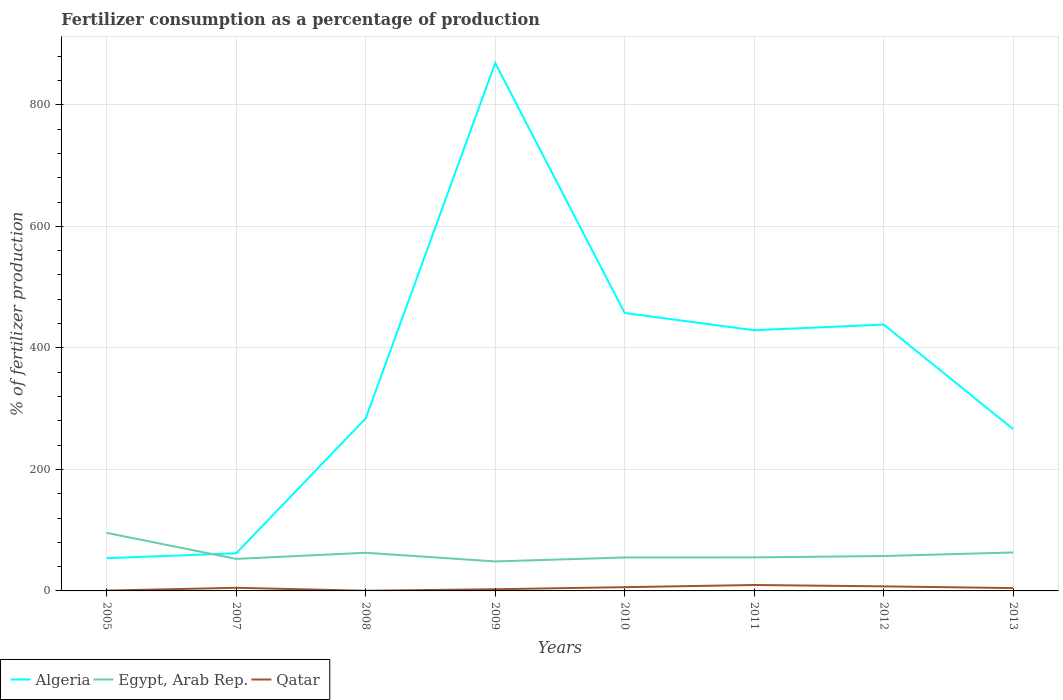Does the line corresponding to Algeria intersect with the line corresponding to Qatar?
Ensure brevity in your answer.  No. Across all years, what is the maximum percentage of fertilizers consumed in Qatar?
Your answer should be very brief. 0.26. In which year was the percentage of fertilizers consumed in Egypt, Arab Rep. maximum?
Your answer should be compact. 2009. What is the total percentage of fertilizers consumed in Algeria in the graph?
Offer a very short reply. 172.19. What is the difference between the highest and the second highest percentage of fertilizers consumed in Algeria?
Provide a succinct answer. 815.1. Is the percentage of fertilizers consumed in Qatar strictly greater than the percentage of fertilizers consumed in Algeria over the years?
Give a very brief answer. Yes. How many lines are there?
Keep it short and to the point. 3. Where does the legend appear in the graph?
Your answer should be very brief. Bottom left. What is the title of the graph?
Keep it short and to the point. Fertilizer consumption as a percentage of production. What is the label or title of the X-axis?
Provide a short and direct response. Years. What is the label or title of the Y-axis?
Offer a very short reply. % of fertilizer production. What is the % of fertilizer production in Algeria in 2005?
Your answer should be very brief. 53.9. What is the % of fertilizer production of Egypt, Arab Rep. in 2005?
Your answer should be compact. 95.53. What is the % of fertilizer production of Qatar in 2005?
Your answer should be compact. 0.54. What is the % of fertilizer production of Algeria in 2007?
Ensure brevity in your answer.  61.95. What is the % of fertilizer production in Egypt, Arab Rep. in 2007?
Provide a succinct answer. 52.73. What is the % of fertilizer production of Qatar in 2007?
Offer a very short reply. 5.16. What is the % of fertilizer production of Algeria in 2008?
Make the answer very short. 283.96. What is the % of fertilizer production of Egypt, Arab Rep. in 2008?
Your answer should be very brief. 62.8. What is the % of fertilizer production of Qatar in 2008?
Give a very brief answer. 0.26. What is the % of fertilizer production of Algeria in 2009?
Provide a succinct answer. 869. What is the % of fertilizer production of Egypt, Arab Rep. in 2009?
Ensure brevity in your answer.  48.52. What is the % of fertilizer production of Qatar in 2009?
Your response must be concise. 2.78. What is the % of fertilizer production in Algeria in 2010?
Make the answer very short. 457.43. What is the % of fertilizer production of Egypt, Arab Rep. in 2010?
Ensure brevity in your answer.  55.04. What is the % of fertilizer production of Qatar in 2010?
Your response must be concise. 6.17. What is the % of fertilizer production in Algeria in 2011?
Make the answer very short. 429.09. What is the % of fertilizer production in Egypt, Arab Rep. in 2011?
Provide a short and direct response. 55.18. What is the % of fertilizer production in Qatar in 2011?
Make the answer very short. 9.75. What is the % of fertilizer production in Algeria in 2012?
Offer a terse response. 438.44. What is the % of fertilizer production in Egypt, Arab Rep. in 2012?
Offer a terse response. 57.44. What is the % of fertilizer production in Qatar in 2012?
Your response must be concise. 7.5. What is the % of fertilizer production in Algeria in 2013?
Your answer should be very brief. 266.25. What is the % of fertilizer production of Egypt, Arab Rep. in 2013?
Offer a terse response. 63.31. What is the % of fertilizer production of Qatar in 2013?
Provide a short and direct response. 4.65. Across all years, what is the maximum % of fertilizer production in Algeria?
Give a very brief answer. 869. Across all years, what is the maximum % of fertilizer production of Egypt, Arab Rep.?
Make the answer very short. 95.53. Across all years, what is the maximum % of fertilizer production in Qatar?
Your response must be concise. 9.75. Across all years, what is the minimum % of fertilizer production in Algeria?
Make the answer very short. 53.9. Across all years, what is the minimum % of fertilizer production of Egypt, Arab Rep.?
Your answer should be compact. 48.52. Across all years, what is the minimum % of fertilizer production in Qatar?
Your response must be concise. 0.26. What is the total % of fertilizer production of Algeria in the graph?
Your answer should be very brief. 2860.02. What is the total % of fertilizer production in Egypt, Arab Rep. in the graph?
Make the answer very short. 490.56. What is the total % of fertilizer production in Qatar in the graph?
Give a very brief answer. 36.81. What is the difference between the % of fertilizer production in Algeria in 2005 and that in 2007?
Give a very brief answer. -8.04. What is the difference between the % of fertilizer production in Egypt, Arab Rep. in 2005 and that in 2007?
Offer a very short reply. 42.8. What is the difference between the % of fertilizer production of Qatar in 2005 and that in 2007?
Provide a succinct answer. -4.63. What is the difference between the % of fertilizer production in Algeria in 2005 and that in 2008?
Offer a terse response. -230.05. What is the difference between the % of fertilizer production of Egypt, Arab Rep. in 2005 and that in 2008?
Keep it short and to the point. 32.74. What is the difference between the % of fertilizer production of Qatar in 2005 and that in 2008?
Your answer should be very brief. 0.28. What is the difference between the % of fertilizer production in Algeria in 2005 and that in 2009?
Your response must be concise. -815.1. What is the difference between the % of fertilizer production in Egypt, Arab Rep. in 2005 and that in 2009?
Make the answer very short. 47.01. What is the difference between the % of fertilizer production of Qatar in 2005 and that in 2009?
Provide a short and direct response. -2.24. What is the difference between the % of fertilizer production in Algeria in 2005 and that in 2010?
Give a very brief answer. -403.53. What is the difference between the % of fertilizer production of Egypt, Arab Rep. in 2005 and that in 2010?
Offer a very short reply. 40.49. What is the difference between the % of fertilizer production of Qatar in 2005 and that in 2010?
Provide a short and direct response. -5.64. What is the difference between the % of fertilizer production of Algeria in 2005 and that in 2011?
Make the answer very short. -375.19. What is the difference between the % of fertilizer production in Egypt, Arab Rep. in 2005 and that in 2011?
Your answer should be very brief. 40.36. What is the difference between the % of fertilizer production in Qatar in 2005 and that in 2011?
Ensure brevity in your answer.  -9.21. What is the difference between the % of fertilizer production of Algeria in 2005 and that in 2012?
Make the answer very short. -384.54. What is the difference between the % of fertilizer production in Egypt, Arab Rep. in 2005 and that in 2012?
Offer a terse response. 38.09. What is the difference between the % of fertilizer production in Qatar in 2005 and that in 2012?
Ensure brevity in your answer.  -6.96. What is the difference between the % of fertilizer production in Algeria in 2005 and that in 2013?
Give a very brief answer. -212.35. What is the difference between the % of fertilizer production of Egypt, Arab Rep. in 2005 and that in 2013?
Give a very brief answer. 32.23. What is the difference between the % of fertilizer production in Qatar in 2005 and that in 2013?
Provide a succinct answer. -4.11. What is the difference between the % of fertilizer production in Algeria in 2007 and that in 2008?
Ensure brevity in your answer.  -222.01. What is the difference between the % of fertilizer production of Egypt, Arab Rep. in 2007 and that in 2008?
Offer a very short reply. -10.07. What is the difference between the % of fertilizer production in Qatar in 2007 and that in 2008?
Your answer should be compact. 4.9. What is the difference between the % of fertilizer production of Algeria in 2007 and that in 2009?
Provide a succinct answer. -807.06. What is the difference between the % of fertilizer production of Egypt, Arab Rep. in 2007 and that in 2009?
Provide a short and direct response. 4.21. What is the difference between the % of fertilizer production in Qatar in 2007 and that in 2009?
Ensure brevity in your answer.  2.38. What is the difference between the % of fertilizer production in Algeria in 2007 and that in 2010?
Your answer should be very brief. -395.49. What is the difference between the % of fertilizer production in Egypt, Arab Rep. in 2007 and that in 2010?
Provide a succinct answer. -2.31. What is the difference between the % of fertilizer production in Qatar in 2007 and that in 2010?
Offer a very short reply. -1.01. What is the difference between the % of fertilizer production in Algeria in 2007 and that in 2011?
Keep it short and to the point. -367.14. What is the difference between the % of fertilizer production in Egypt, Arab Rep. in 2007 and that in 2011?
Your answer should be very brief. -2.45. What is the difference between the % of fertilizer production of Qatar in 2007 and that in 2011?
Keep it short and to the point. -4.59. What is the difference between the % of fertilizer production in Algeria in 2007 and that in 2012?
Provide a short and direct response. -376.49. What is the difference between the % of fertilizer production in Egypt, Arab Rep. in 2007 and that in 2012?
Offer a terse response. -4.71. What is the difference between the % of fertilizer production of Qatar in 2007 and that in 2012?
Provide a short and direct response. -2.34. What is the difference between the % of fertilizer production of Algeria in 2007 and that in 2013?
Provide a succinct answer. -204.3. What is the difference between the % of fertilizer production of Egypt, Arab Rep. in 2007 and that in 2013?
Your answer should be very brief. -10.58. What is the difference between the % of fertilizer production of Qatar in 2007 and that in 2013?
Provide a succinct answer. 0.51. What is the difference between the % of fertilizer production in Algeria in 2008 and that in 2009?
Give a very brief answer. -585.05. What is the difference between the % of fertilizer production of Egypt, Arab Rep. in 2008 and that in 2009?
Provide a succinct answer. 14.28. What is the difference between the % of fertilizer production in Qatar in 2008 and that in 2009?
Make the answer very short. -2.52. What is the difference between the % of fertilizer production in Algeria in 2008 and that in 2010?
Make the answer very short. -173.48. What is the difference between the % of fertilizer production in Egypt, Arab Rep. in 2008 and that in 2010?
Your response must be concise. 7.76. What is the difference between the % of fertilizer production of Qatar in 2008 and that in 2010?
Give a very brief answer. -5.91. What is the difference between the % of fertilizer production of Algeria in 2008 and that in 2011?
Keep it short and to the point. -145.13. What is the difference between the % of fertilizer production of Egypt, Arab Rep. in 2008 and that in 2011?
Provide a short and direct response. 7.62. What is the difference between the % of fertilizer production in Qatar in 2008 and that in 2011?
Provide a short and direct response. -9.49. What is the difference between the % of fertilizer production in Algeria in 2008 and that in 2012?
Provide a succinct answer. -154.48. What is the difference between the % of fertilizer production in Egypt, Arab Rep. in 2008 and that in 2012?
Your response must be concise. 5.36. What is the difference between the % of fertilizer production in Qatar in 2008 and that in 2012?
Your answer should be compact. -7.24. What is the difference between the % of fertilizer production in Algeria in 2008 and that in 2013?
Ensure brevity in your answer.  17.71. What is the difference between the % of fertilizer production of Egypt, Arab Rep. in 2008 and that in 2013?
Give a very brief answer. -0.51. What is the difference between the % of fertilizer production in Qatar in 2008 and that in 2013?
Offer a terse response. -4.39. What is the difference between the % of fertilizer production of Algeria in 2009 and that in 2010?
Your response must be concise. 411.57. What is the difference between the % of fertilizer production in Egypt, Arab Rep. in 2009 and that in 2010?
Offer a terse response. -6.52. What is the difference between the % of fertilizer production in Qatar in 2009 and that in 2010?
Keep it short and to the point. -3.4. What is the difference between the % of fertilizer production of Algeria in 2009 and that in 2011?
Provide a succinct answer. 439.91. What is the difference between the % of fertilizer production in Egypt, Arab Rep. in 2009 and that in 2011?
Your answer should be very brief. -6.66. What is the difference between the % of fertilizer production in Qatar in 2009 and that in 2011?
Give a very brief answer. -6.97. What is the difference between the % of fertilizer production in Algeria in 2009 and that in 2012?
Provide a succinct answer. 430.57. What is the difference between the % of fertilizer production of Egypt, Arab Rep. in 2009 and that in 2012?
Your response must be concise. -8.92. What is the difference between the % of fertilizer production of Qatar in 2009 and that in 2012?
Offer a terse response. -4.72. What is the difference between the % of fertilizer production of Algeria in 2009 and that in 2013?
Your response must be concise. 602.76. What is the difference between the % of fertilizer production of Egypt, Arab Rep. in 2009 and that in 2013?
Your response must be concise. -14.79. What is the difference between the % of fertilizer production in Qatar in 2009 and that in 2013?
Keep it short and to the point. -1.87. What is the difference between the % of fertilizer production of Algeria in 2010 and that in 2011?
Keep it short and to the point. 28.34. What is the difference between the % of fertilizer production in Egypt, Arab Rep. in 2010 and that in 2011?
Ensure brevity in your answer.  -0.14. What is the difference between the % of fertilizer production of Qatar in 2010 and that in 2011?
Your response must be concise. -3.57. What is the difference between the % of fertilizer production in Algeria in 2010 and that in 2012?
Make the answer very short. 18.99. What is the difference between the % of fertilizer production of Egypt, Arab Rep. in 2010 and that in 2012?
Offer a terse response. -2.4. What is the difference between the % of fertilizer production in Qatar in 2010 and that in 2012?
Offer a very short reply. -1.33. What is the difference between the % of fertilizer production in Algeria in 2010 and that in 2013?
Provide a succinct answer. 191.18. What is the difference between the % of fertilizer production in Egypt, Arab Rep. in 2010 and that in 2013?
Your answer should be very brief. -8.27. What is the difference between the % of fertilizer production in Qatar in 2010 and that in 2013?
Provide a short and direct response. 1.52. What is the difference between the % of fertilizer production in Algeria in 2011 and that in 2012?
Offer a very short reply. -9.35. What is the difference between the % of fertilizer production of Egypt, Arab Rep. in 2011 and that in 2012?
Your answer should be compact. -2.26. What is the difference between the % of fertilizer production of Qatar in 2011 and that in 2012?
Keep it short and to the point. 2.25. What is the difference between the % of fertilizer production in Algeria in 2011 and that in 2013?
Your answer should be very brief. 162.84. What is the difference between the % of fertilizer production of Egypt, Arab Rep. in 2011 and that in 2013?
Keep it short and to the point. -8.13. What is the difference between the % of fertilizer production of Qatar in 2011 and that in 2013?
Make the answer very short. 5.1. What is the difference between the % of fertilizer production in Algeria in 2012 and that in 2013?
Keep it short and to the point. 172.19. What is the difference between the % of fertilizer production in Egypt, Arab Rep. in 2012 and that in 2013?
Your response must be concise. -5.87. What is the difference between the % of fertilizer production of Qatar in 2012 and that in 2013?
Keep it short and to the point. 2.85. What is the difference between the % of fertilizer production in Algeria in 2005 and the % of fertilizer production in Egypt, Arab Rep. in 2007?
Your answer should be very brief. 1.17. What is the difference between the % of fertilizer production in Algeria in 2005 and the % of fertilizer production in Qatar in 2007?
Offer a terse response. 48.74. What is the difference between the % of fertilizer production in Egypt, Arab Rep. in 2005 and the % of fertilizer production in Qatar in 2007?
Your answer should be compact. 90.37. What is the difference between the % of fertilizer production of Algeria in 2005 and the % of fertilizer production of Egypt, Arab Rep. in 2008?
Provide a succinct answer. -8.9. What is the difference between the % of fertilizer production in Algeria in 2005 and the % of fertilizer production in Qatar in 2008?
Your answer should be very brief. 53.64. What is the difference between the % of fertilizer production in Egypt, Arab Rep. in 2005 and the % of fertilizer production in Qatar in 2008?
Provide a short and direct response. 95.27. What is the difference between the % of fertilizer production of Algeria in 2005 and the % of fertilizer production of Egypt, Arab Rep. in 2009?
Ensure brevity in your answer.  5.38. What is the difference between the % of fertilizer production of Algeria in 2005 and the % of fertilizer production of Qatar in 2009?
Your response must be concise. 51.13. What is the difference between the % of fertilizer production in Egypt, Arab Rep. in 2005 and the % of fertilizer production in Qatar in 2009?
Keep it short and to the point. 92.76. What is the difference between the % of fertilizer production of Algeria in 2005 and the % of fertilizer production of Egypt, Arab Rep. in 2010?
Offer a terse response. -1.14. What is the difference between the % of fertilizer production in Algeria in 2005 and the % of fertilizer production in Qatar in 2010?
Provide a succinct answer. 47.73. What is the difference between the % of fertilizer production of Egypt, Arab Rep. in 2005 and the % of fertilizer production of Qatar in 2010?
Offer a terse response. 89.36. What is the difference between the % of fertilizer production of Algeria in 2005 and the % of fertilizer production of Egypt, Arab Rep. in 2011?
Your answer should be compact. -1.28. What is the difference between the % of fertilizer production of Algeria in 2005 and the % of fertilizer production of Qatar in 2011?
Provide a short and direct response. 44.15. What is the difference between the % of fertilizer production of Egypt, Arab Rep. in 2005 and the % of fertilizer production of Qatar in 2011?
Offer a terse response. 85.79. What is the difference between the % of fertilizer production in Algeria in 2005 and the % of fertilizer production in Egypt, Arab Rep. in 2012?
Make the answer very short. -3.54. What is the difference between the % of fertilizer production of Algeria in 2005 and the % of fertilizer production of Qatar in 2012?
Your answer should be very brief. 46.4. What is the difference between the % of fertilizer production in Egypt, Arab Rep. in 2005 and the % of fertilizer production in Qatar in 2012?
Your answer should be compact. 88.03. What is the difference between the % of fertilizer production of Algeria in 2005 and the % of fertilizer production of Egypt, Arab Rep. in 2013?
Ensure brevity in your answer.  -9.41. What is the difference between the % of fertilizer production of Algeria in 2005 and the % of fertilizer production of Qatar in 2013?
Give a very brief answer. 49.25. What is the difference between the % of fertilizer production in Egypt, Arab Rep. in 2005 and the % of fertilizer production in Qatar in 2013?
Provide a short and direct response. 90.88. What is the difference between the % of fertilizer production in Algeria in 2007 and the % of fertilizer production in Egypt, Arab Rep. in 2008?
Give a very brief answer. -0.85. What is the difference between the % of fertilizer production of Algeria in 2007 and the % of fertilizer production of Qatar in 2008?
Keep it short and to the point. 61.69. What is the difference between the % of fertilizer production of Egypt, Arab Rep. in 2007 and the % of fertilizer production of Qatar in 2008?
Ensure brevity in your answer.  52.47. What is the difference between the % of fertilizer production in Algeria in 2007 and the % of fertilizer production in Egypt, Arab Rep. in 2009?
Ensure brevity in your answer.  13.43. What is the difference between the % of fertilizer production of Algeria in 2007 and the % of fertilizer production of Qatar in 2009?
Keep it short and to the point. 59.17. What is the difference between the % of fertilizer production of Egypt, Arab Rep. in 2007 and the % of fertilizer production of Qatar in 2009?
Keep it short and to the point. 49.95. What is the difference between the % of fertilizer production of Algeria in 2007 and the % of fertilizer production of Egypt, Arab Rep. in 2010?
Your response must be concise. 6.9. What is the difference between the % of fertilizer production of Algeria in 2007 and the % of fertilizer production of Qatar in 2010?
Your answer should be compact. 55.77. What is the difference between the % of fertilizer production in Egypt, Arab Rep. in 2007 and the % of fertilizer production in Qatar in 2010?
Provide a short and direct response. 46.56. What is the difference between the % of fertilizer production in Algeria in 2007 and the % of fertilizer production in Egypt, Arab Rep. in 2011?
Your answer should be very brief. 6.77. What is the difference between the % of fertilizer production in Algeria in 2007 and the % of fertilizer production in Qatar in 2011?
Keep it short and to the point. 52.2. What is the difference between the % of fertilizer production in Egypt, Arab Rep. in 2007 and the % of fertilizer production in Qatar in 2011?
Give a very brief answer. 42.98. What is the difference between the % of fertilizer production in Algeria in 2007 and the % of fertilizer production in Egypt, Arab Rep. in 2012?
Provide a succinct answer. 4.51. What is the difference between the % of fertilizer production in Algeria in 2007 and the % of fertilizer production in Qatar in 2012?
Your answer should be compact. 54.45. What is the difference between the % of fertilizer production in Egypt, Arab Rep. in 2007 and the % of fertilizer production in Qatar in 2012?
Your response must be concise. 45.23. What is the difference between the % of fertilizer production in Algeria in 2007 and the % of fertilizer production in Egypt, Arab Rep. in 2013?
Make the answer very short. -1.36. What is the difference between the % of fertilizer production in Algeria in 2007 and the % of fertilizer production in Qatar in 2013?
Ensure brevity in your answer.  57.3. What is the difference between the % of fertilizer production in Egypt, Arab Rep. in 2007 and the % of fertilizer production in Qatar in 2013?
Give a very brief answer. 48.08. What is the difference between the % of fertilizer production in Algeria in 2008 and the % of fertilizer production in Egypt, Arab Rep. in 2009?
Offer a terse response. 235.43. What is the difference between the % of fertilizer production in Algeria in 2008 and the % of fertilizer production in Qatar in 2009?
Make the answer very short. 281.18. What is the difference between the % of fertilizer production of Egypt, Arab Rep. in 2008 and the % of fertilizer production of Qatar in 2009?
Ensure brevity in your answer.  60.02. What is the difference between the % of fertilizer production in Algeria in 2008 and the % of fertilizer production in Egypt, Arab Rep. in 2010?
Offer a terse response. 228.91. What is the difference between the % of fertilizer production of Algeria in 2008 and the % of fertilizer production of Qatar in 2010?
Your answer should be very brief. 277.78. What is the difference between the % of fertilizer production of Egypt, Arab Rep. in 2008 and the % of fertilizer production of Qatar in 2010?
Offer a terse response. 56.63. What is the difference between the % of fertilizer production in Algeria in 2008 and the % of fertilizer production in Egypt, Arab Rep. in 2011?
Offer a very short reply. 228.78. What is the difference between the % of fertilizer production in Algeria in 2008 and the % of fertilizer production in Qatar in 2011?
Your answer should be compact. 274.21. What is the difference between the % of fertilizer production of Egypt, Arab Rep. in 2008 and the % of fertilizer production of Qatar in 2011?
Your response must be concise. 53.05. What is the difference between the % of fertilizer production of Algeria in 2008 and the % of fertilizer production of Egypt, Arab Rep. in 2012?
Offer a terse response. 226.51. What is the difference between the % of fertilizer production of Algeria in 2008 and the % of fertilizer production of Qatar in 2012?
Provide a short and direct response. 276.46. What is the difference between the % of fertilizer production in Egypt, Arab Rep. in 2008 and the % of fertilizer production in Qatar in 2012?
Make the answer very short. 55.3. What is the difference between the % of fertilizer production in Algeria in 2008 and the % of fertilizer production in Egypt, Arab Rep. in 2013?
Keep it short and to the point. 220.65. What is the difference between the % of fertilizer production in Algeria in 2008 and the % of fertilizer production in Qatar in 2013?
Offer a very short reply. 279.31. What is the difference between the % of fertilizer production in Egypt, Arab Rep. in 2008 and the % of fertilizer production in Qatar in 2013?
Keep it short and to the point. 58.15. What is the difference between the % of fertilizer production in Algeria in 2009 and the % of fertilizer production in Egypt, Arab Rep. in 2010?
Give a very brief answer. 813.96. What is the difference between the % of fertilizer production of Algeria in 2009 and the % of fertilizer production of Qatar in 2010?
Your answer should be very brief. 862.83. What is the difference between the % of fertilizer production of Egypt, Arab Rep. in 2009 and the % of fertilizer production of Qatar in 2010?
Give a very brief answer. 42.35. What is the difference between the % of fertilizer production in Algeria in 2009 and the % of fertilizer production in Egypt, Arab Rep. in 2011?
Offer a very short reply. 813.83. What is the difference between the % of fertilizer production in Algeria in 2009 and the % of fertilizer production in Qatar in 2011?
Ensure brevity in your answer.  859.26. What is the difference between the % of fertilizer production of Egypt, Arab Rep. in 2009 and the % of fertilizer production of Qatar in 2011?
Make the answer very short. 38.77. What is the difference between the % of fertilizer production of Algeria in 2009 and the % of fertilizer production of Egypt, Arab Rep. in 2012?
Provide a short and direct response. 811.56. What is the difference between the % of fertilizer production in Algeria in 2009 and the % of fertilizer production in Qatar in 2012?
Keep it short and to the point. 861.51. What is the difference between the % of fertilizer production in Egypt, Arab Rep. in 2009 and the % of fertilizer production in Qatar in 2012?
Offer a very short reply. 41.02. What is the difference between the % of fertilizer production in Algeria in 2009 and the % of fertilizer production in Egypt, Arab Rep. in 2013?
Ensure brevity in your answer.  805.7. What is the difference between the % of fertilizer production in Algeria in 2009 and the % of fertilizer production in Qatar in 2013?
Make the answer very short. 864.35. What is the difference between the % of fertilizer production in Egypt, Arab Rep. in 2009 and the % of fertilizer production in Qatar in 2013?
Offer a very short reply. 43.87. What is the difference between the % of fertilizer production of Algeria in 2010 and the % of fertilizer production of Egypt, Arab Rep. in 2011?
Provide a succinct answer. 402.25. What is the difference between the % of fertilizer production in Algeria in 2010 and the % of fertilizer production in Qatar in 2011?
Provide a short and direct response. 447.69. What is the difference between the % of fertilizer production in Egypt, Arab Rep. in 2010 and the % of fertilizer production in Qatar in 2011?
Your answer should be very brief. 45.3. What is the difference between the % of fertilizer production in Algeria in 2010 and the % of fertilizer production in Egypt, Arab Rep. in 2012?
Offer a very short reply. 399.99. What is the difference between the % of fertilizer production in Algeria in 2010 and the % of fertilizer production in Qatar in 2012?
Offer a terse response. 449.93. What is the difference between the % of fertilizer production in Egypt, Arab Rep. in 2010 and the % of fertilizer production in Qatar in 2012?
Provide a short and direct response. 47.54. What is the difference between the % of fertilizer production in Algeria in 2010 and the % of fertilizer production in Egypt, Arab Rep. in 2013?
Make the answer very short. 394.12. What is the difference between the % of fertilizer production of Algeria in 2010 and the % of fertilizer production of Qatar in 2013?
Your answer should be very brief. 452.78. What is the difference between the % of fertilizer production of Egypt, Arab Rep. in 2010 and the % of fertilizer production of Qatar in 2013?
Offer a terse response. 50.39. What is the difference between the % of fertilizer production in Algeria in 2011 and the % of fertilizer production in Egypt, Arab Rep. in 2012?
Give a very brief answer. 371.65. What is the difference between the % of fertilizer production of Algeria in 2011 and the % of fertilizer production of Qatar in 2012?
Ensure brevity in your answer.  421.59. What is the difference between the % of fertilizer production of Egypt, Arab Rep. in 2011 and the % of fertilizer production of Qatar in 2012?
Keep it short and to the point. 47.68. What is the difference between the % of fertilizer production in Algeria in 2011 and the % of fertilizer production in Egypt, Arab Rep. in 2013?
Your answer should be compact. 365.78. What is the difference between the % of fertilizer production of Algeria in 2011 and the % of fertilizer production of Qatar in 2013?
Provide a short and direct response. 424.44. What is the difference between the % of fertilizer production in Egypt, Arab Rep. in 2011 and the % of fertilizer production in Qatar in 2013?
Keep it short and to the point. 50.53. What is the difference between the % of fertilizer production of Algeria in 2012 and the % of fertilizer production of Egypt, Arab Rep. in 2013?
Your response must be concise. 375.13. What is the difference between the % of fertilizer production in Algeria in 2012 and the % of fertilizer production in Qatar in 2013?
Keep it short and to the point. 433.79. What is the difference between the % of fertilizer production in Egypt, Arab Rep. in 2012 and the % of fertilizer production in Qatar in 2013?
Provide a short and direct response. 52.79. What is the average % of fertilizer production of Algeria per year?
Give a very brief answer. 357.5. What is the average % of fertilizer production in Egypt, Arab Rep. per year?
Your answer should be very brief. 61.32. What is the average % of fertilizer production in Qatar per year?
Your answer should be very brief. 4.6. In the year 2005, what is the difference between the % of fertilizer production of Algeria and % of fertilizer production of Egypt, Arab Rep.?
Provide a short and direct response. -41.63. In the year 2005, what is the difference between the % of fertilizer production of Algeria and % of fertilizer production of Qatar?
Your response must be concise. 53.37. In the year 2005, what is the difference between the % of fertilizer production in Egypt, Arab Rep. and % of fertilizer production in Qatar?
Your answer should be compact. 95. In the year 2007, what is the difference between the % of fertilizer production of Algeria and % of fertilizer production of Egypt, Arab Rep.?
Ensure brevity in your answer.  9.22. In the year 2007, what is the difference between the % of fertilizer production in Algeria and % of fertilizer production in Qatar?
Your response must be concise. 56.79. In the year 2007, what is the difference between the % of fertilizer production in Egypt, Arab Rep. and % of fertilizer production in Qatar?
Provide a short and direct response. 47.57. In the year 2008, what is the difference between the % of fertilizer production in Algeria and % of fertilizer production in Egypt, Arab Rep.?
Your answer should be compact. 221.16. In the year 2008, what is the difference between the % of fertilizer production of Algeria and % of fertilizer production of Qatar?
Offer a terse response. 283.7. In the year 2008, what is the difference between the % of fertilizer production of Egypt, Arab Rep. and % of fertilizer production of Qatar?
Make the answer very short. 62.54. In the year 2009, what is the difference between the % of fertilizer production in Algeria and % of fertilizer production in Egypt, Arab Rep.?
Your answer should be very brief. 820.48. In the year 2009, what is the difference between the % of fertilizer production in Algeria and % of fertilizer production in Qatar?
Give a very brief answer. 866.23. In the year 2009, what is the difference between the % of fertilizer production in Egypt, Arab Rep. and % of fertilizer production in Qatar?
Your response must be concise. 45.75. In the year 2010, what is the difference between the % of fertilizer production in Algeria and % of fertilizer production in Egypt, Arab Rep.?
Your answer should be compact. 402.39. In the year 2010, what is the difference between the % of fertilizer production of Algeria and % of fertilizer production of Qatar?
Offer a terse response. 451.26. In the year 2010, what is the difference between the % of fertilizer production of Egypt, Arab Rep. and % of fertilizer production of Qatar?
Your response must be concise. 48.87. In the year 2011, what is the difference between the % of fertilizer production in Algeria and % of fertilizer production in Egypt, Arab Rep.?
Offer a very short reply. 373.91. In the year 2011, what is the difference between the % of fertilizer production of Algeria and % of fertilizer production of Qatar?
Ensure brevity in your answer.  419.34. In the year 2011, what is the difference between the % of fertilizer production of Egypt, Arab Rep. and % of fertilizer production of Qatar?
Ensure brevity in your answer.  45.43. In the year 2012, what is the difference between the % of fertilizer production of Algeria and % of fertilizer production of Egypt, Arab Rep.?
Make the answer very short. 381. In the year 2012, what is the difference between the % of fertilizer production in Algeria and % of fertilizer production in Qatar?
Make the answer very short. 430.94. In the year 2012, what is the difference between the % of fertilizer production in Egypt, Arab Rep. and % of fertilizer production in Qatar?
Make the answer very short. 49.94. In the year 2013, what is the difference between the % of fertilizer production in Algeria and % of fertilizer production in Egypt, Arab Rep.?
Your answer should be very brief. 202.94. In the year 2013, what is the difference between the % of fertilizer production of Algeria and % of fertilizer production of Qatar?
Ensure brevity in your answer.  261.6. In the year 2013, what is the difference between the % of fertilizer production of Egypt, Arab Rep. and % of fertilizer production of Qatar?
Give a very brief answer. 58.66. What is the ratio of the % of fertilizer production of Algeria in 2005 to that in 2007?
Provide a succinct answer. 0.87. What is the ratio of the % of fertilizer production of Egypt, Arab Rep. in 2005 to that in 2007?
Ensure brevity in your answer.  1.81. What is the ratio of the % of fertilizer production of Qatar in 2005 to that in 2007?
Offer a very short reply. 0.1. What is the ratio of the % of fertilizer production of Algeria in 2005 to that in 2008?
Make the answer very short. 0.19. What is the ratio of the % of fertilizer production of Egypt, Arab Rep. in 2005 to that in 2008?
Your answer should be compact. 1.52. What is the ratio of the % of fertilizer production of Qatar in 2005 to that in 2008?
Give a very brief answer. 2.05. What is the ratio of the % of fertilizer production in Algeria in 2005 to that in 2009?
Your response must be concise. 0.06. What is the ratio of the % of fertilizer production of Egypt, Arab Rep. in 2005 to that in 2009?
Give a very brief answer. 1.97. What is the ratio of the % of fertilizer production in Qatar in 2005 to that in 2009?
Provide a short and direct response. 0.19. What is the ratio of the % of fertilizer production in Algeria in 2005 to that in 2010?
Offer a very short reply. 0.12. What is the ratio of the % of fertilizer production of Egypt, Arab Rep. in 2005 to that in 2010?
Offer a terse response. 1.74. What is the ratio of the % of fertilizer production in Qatar in 2005 to that in 2010?
Offer a terse response. 0.09. What is the ratio of the % of fertilizer production in Algeria in 2005 to that in 2011?
Offer a very short reply. 0.13. What is the ratio of the % of fertilizer production of Egypt, Arab Rep. in 2005 to that in 2011?
Your response must be concise. 1.73. What is the ratio of the % of fertilizer production in Qatar in 2005 to that in 2011?
Make the answer very short. 0.06. What is the ratio of the % of fertilizer production of Algeria in 2005 to that in 2012?
Your response must be concise. 0.12. What is the ratio of the % of fertilizer production in Egypt, Arab Rep. in 2005 to that in 2012?
Offer a very short reply. 1.66. What is the ratio of the % of fertilizer production of Qatar in 2005 to that in 2012?
Offer a very short reply. 0.07. What is the ratio of the % of fertilizer production of Algeria in 2005 to that in 2013?
Keep it short and to the point. 0.2. What is the ratio of the % of fertilizer production of Egypt, Arab Rep. in 2005 to that in 2013?
Your answer should be compact. 1.51. What is the ratio of the % of fertilizer production in Qatar in 2005 to that in 2013?
Give a very brief answer. 0.12. What is the ratio of the % of fertilizer production of Algeria in 2007 to that in 2008?
Keep it short and to the point. 0.22. What is the ratio of the % of fertilizer production in Egypt, Arab Rep. in 2007 to that in 2008?
Keep it short and to the point. 0.84. What is the ratio of the % of fertilizer production in Qatar in 2007 to that in 2008?
Make the answer very short. 19.77. What is the ratio of the % of fertilizer production in Algeria in 2007 to that in 2009?
Your response must be concise. 0.07. What is the ratio of the % of fertilizer production of Egypt, Arab Rep. in 2007 to that in 2009?
Your response must be concise. 1.09. What is the ratio of the % of fertilizer production in Qatar in 2007 to that in 2009?
Give a very brief answer. 1.86. What is the ratio of the % of fertilizer production in Algeria in 2007 to that in 2010?
Provide a succinct answer. 0.14. What is the ratio of the % of fertilizer production of Egypt, Arab Rep. in 2007 to that in 2010?
Offer a very short reply. 0.96. What is the ratio of the % of fertilizer production in Qatar in 2007 to that in 2010?
Make the answer very short. 0.84. What is the ratio of the % of fertilizer production of Algeria in 2007 to that in 2011?
Offer a very short reply. 0.14. What is the ratio of the % of fertilizer production in Egypt, Arab Rep. in 2007 to that in 2011?
Your response must be concise. 0.96. What is the ratio of the % of fertilizer production of Qatar in 2007 to that in 2011?
Keep it short and to the point. 0.53. What is the ratio of the % of fertilizer production in Algeria in 2007 to that in 2012?
Provide a succinct answer. 0.14. What is the ratio of the % of fertilizer production in Egypt, Arab Rep. in 2007 to that in 2012?
Your answer should be compact. 0.92. What is the ratio of the % of fertilizer production of Qatar in 2007 to that in 2012?
Your answer should be compact. 0.69. What is the ratio of the % of fertilizer production of Algeria in 2007 to that in 2013?
Give a very brief answer. 0.23. What is the ratio of the % of fertilizer production of Egypt, Arab Rep. in 2007 to that in 2013?
Provide a short and direct response. 0.83. What is the ratio of the % of fertilizer production in Qatar in 2007 to that in 2013?
Give a very brief answer. 1.11. What is the ratio of the % of fertilizer production of Algeria in 2008 to that in 2009?
Your answer should be very brief. 0.33. What is the ratio of the % of fertilizer production in Egypt, Arab Rep. in 2008 to that in 2009?
Offer a very short reply. 1.29. What is the ratio of the % of fertilizer production of Qatar in 2008 to that in 2009?
Keep it short and to the point. 0.09. What is the ratio of the % of fertilizer production of Algeria in 2008 to that in 2010?
Offer a very short reply. 0.62. What is the ratio of the % of fertilizer production in Egypt, Arab Rep. in 2008 to that in 2010?
Provide a short and direct response. 1.14. What is the ratio of the % of fertilizer production of Qatar in 2008 to that in 2010?
Your answer should be compact. 0.04. What is the ratio of the % of fertilizer production in Algeria in 2008 to that in 2011?
Ensure brevity in your answer.  0.66. What is the ratio of the % of fertilizer production in Egypt, Arab Rep. in 2008 to that in 2011?
Offer a very short reply. 1.14. What is the ratio of the % of fertilizer production in Qatar in 2008 to that in 2011?
Provide a short and direct response. 0.03. What is the ratio of the % of fertilizer production of Algeria in 2008 to that in 2012?
Make the answer very short. 0.65. What is the ratio of the % of fertilizer production in Egypt, Arab Rep. in 2008 to that in 2012?
Provide a succinct answer. 1.09. What is the ratio of the % of fertilizer production in Qatar in 2008 to that in 2012?
Your response must be concise. 0.03. What is the ratio of the % of fertilizer production of Algeria in 2008 to that in 2013?
Ensure brevity in your answer.  1.07. What is the ratio of the % of fertilizer production in Egypt, Arab Rep. in 2008 to that in 2013?
Keep it short and to the point. 0.99. What is the ratio of the % of fertilizer production in Qatar in 2008 to that in 2013?
Offer a very short reply. 0.06. What is the ratio of the % of fertilizer production of Algeria in 2009 to that in 2010?
Provide a short and direct response. 1.9. What is the ratio of the % of fertilizer production of Egypt, Arab Rep. in 2009 to that in 2010?
Keep it short and to the point. 0.88. What is the ratio of the % of fertilizer production in Qatar in 2009 to that in 2010?
Your response must be concise. 0.45. What is the ratio of the % of fertilizer production in Algeria in 2009 to that in 2011?
Keep it short and to the point. 2.03. What is the ratio of the % of fertilizer production of Egypt, Arab Rep. in 2009 to that in 2011?
Ensure brevity in your answer.  0.88. What is the ratio of the % of fertilizer production in Qatar in 2009 to that in 2011?
Your answer should be compact. 0.28. What is the ratio of the % of fertilizer production of Algeria in 2009 to that in 2012?
Your response must be concise. 1.98. What is the ratio of the % of fertilizer production of Egypt, Arab Rep. in 2009 to that in 2012?
Ensure brevity in your answer.  0.84. What is the ratio of the % of fertilizer production of Qatar in 2009 to that in 2012?
Keep it short and to the point. 0.37. What is the ratio of the % of fertilizer production in Algeria in 2009 to that in 2013?
Provide a succinct answer. 3.26. What is the ratio of the % of fertilizer production in Egypt, Arab Rep. in 2009 to that in 2013?
Give a very brief answer. 0.77. What is the ratio of the % of fertilizer production in Qatar in 2009 to that in 2013?
Provide a succinct answer. 0.6. What is the ratio of the % of fertilizer production of Algeria in 2010 to that in 2011?
Your answer should be very brief. 1.07. What is the ratio of the % of fertilizer production of Qatar in 2010 to that in 2011?
Keep it short and to the point. 0.63. What is the ratio of the % of fertilizer production of Algeria in 2010 to that in 2012?
Make the answer very short. 1.04. What is the ratio of the % of fertilizer production of Qatar in 2010 to that in 2012?
Offer a terse response. 0.82. What is the ratio of the % of fertilizer production of Algeria in 2010 to that in 2013?
Give a very brief answer. 1.72. What is the ratio of the % of fertilizer production of Egypt, Arab Rep. in 2010 to that in 2013?
Your answer should be compact. 0.87. What is the ratio of the % of fertilizer production in Qatar in 2010 to that in 2013?
Your answer should be very brief. 1.33. What is the ratio of the % of fertilizer production of Algeria in 2011 to that in 2012?
Provide a short and direct response. 0.98. What is the ratio of the % of fertilizer production in Egypt, Arab Rep. in 2011 to that in 2012?
Provide a short and direct response. 0.96. What is the ratio of the % of fertilizer production in Qatar in 2011 to that in 2012?
Keep it short and to the point. 1.3. What is the ratio of the % of fertilizer production of Algeria in 2011 to that in 2013?
Your response must be concise. 1.61. What is the ratio of the % of fertilizer production in Egypt, Arab Rep. in 2011 to that in 2013?
Provide a succinct answer. 0.87. What is the ratio of the % of fertilizer production of Qatar in 2011 to that in 2013?
Give a very brief answer. 2.1. What is the ratio of the % of fertilizer production in Algeria in 2012 to that in 2013?
Offer a terse response. 1.65. What is the ratio of the % of fertilizer production of Egypt, Arab Rep. in 2012 to that in 2013?
Your response must be concise. 0.91. What is the ratio of the % of fertilizer production in Qatar in 2012 to that in 2013?
Provide a short and direct response. 1.61. What is the difference between the highest and the second highest % of fertilizer production of Algeria?
Your response must be concise. 411.57. What is the difference between the highest and the second highest % of fertilizer production of Egypt, Arab Rep.?
Your answer should be compact. 32.23. What is the difference between the highest and the second highest % of fertilizer production in Qatar?
Provide a short and direct response. 2.25. What is the difference between the highest and the lowest % of fertilizer production of Algeria?
Provide a short and direct response. 815.1. What is the difference between the highest and the lowest % of fertilizer production of Egypt, Arab Rep.?
Ensure brevity in your answer.  47.01. What is the difference between the highest and the lowest % of fertilizer production of Qatar?
Keep it short and to the point. 9.49. 